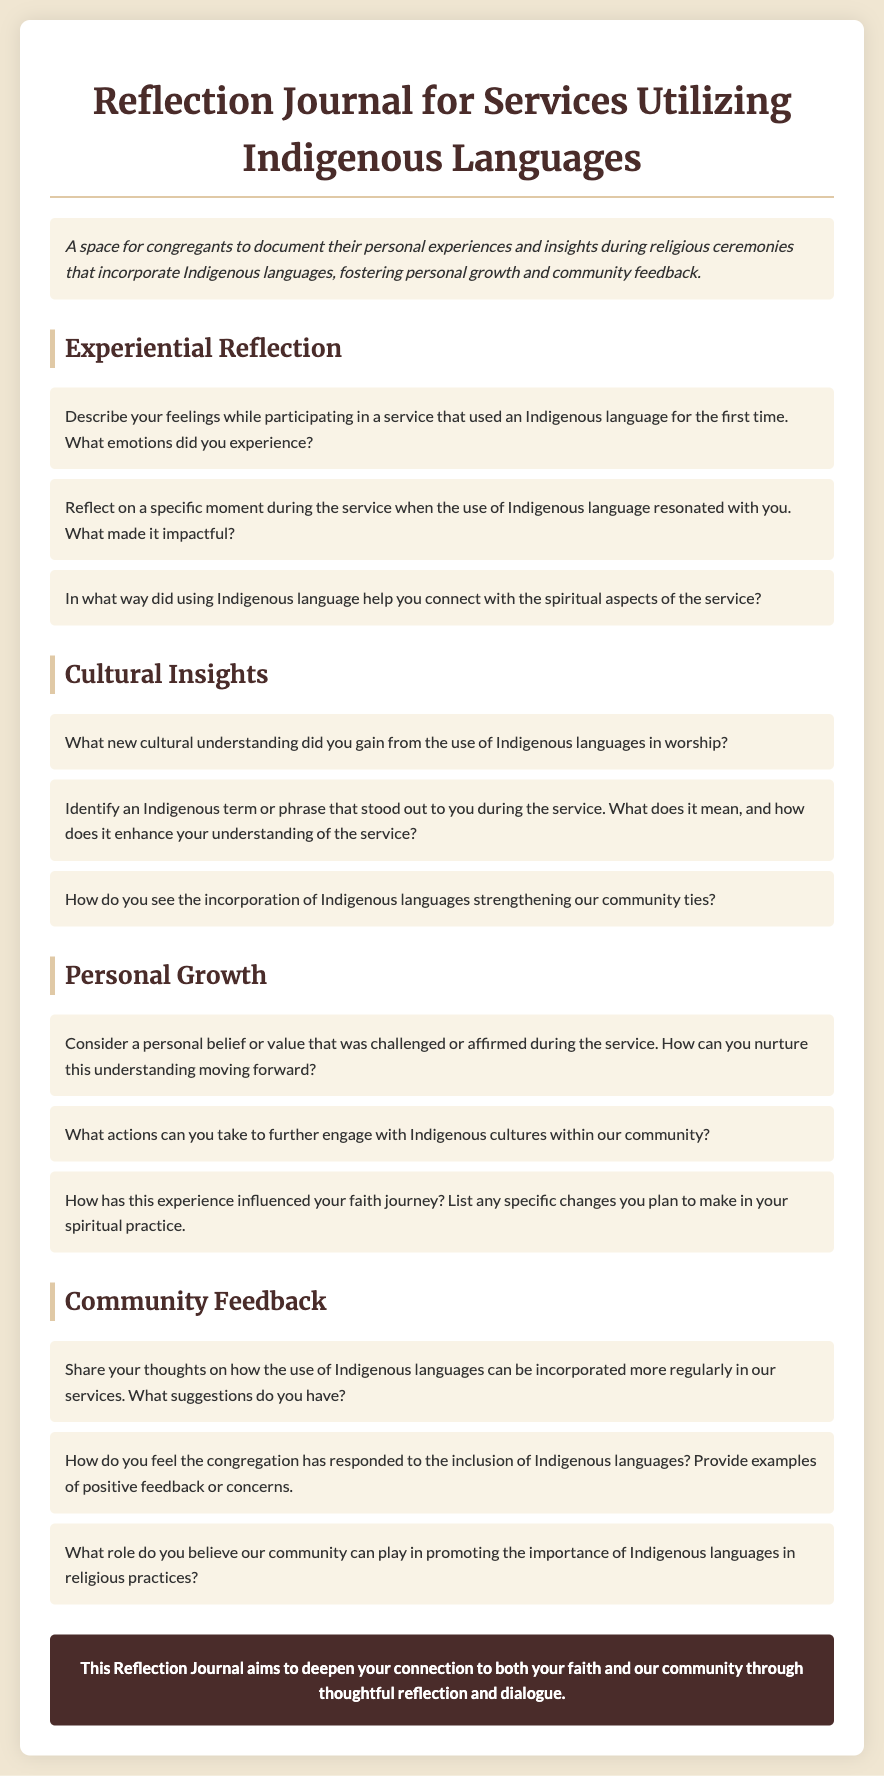what is the title of the reflection journal? The title is prominently displayed at the top of the document.
Answer: Reflection Journal for Services Utilizing Indigenous Languages what is the purpose of the journal? The purpose section describes the intention behind the journal.
Answer: A space for congregants to document their personal experiences and insights during religious ceremonies that incorporate Indigenous languages, fostering personal growth and community feedback how many sections are there in the document? The document contains multiple sections, and each section is clearly defined with a heading.
Answer: Four what is one prompt from the "Experiential Reflection" section? The document lists several prompts under this section.
Answer: Describe your feelings while participating in a service that used an Indigenous language for the first time. What emotions did you experience? which section discusses community feedback? This section is explicitly mentioned in the headings throughout the document.
Answer: Community Feedback what is the background color of the journal's body? The body color is specified in the styling section of the document.
Answer: #f0e6d2 what type of language is focused on in the journal? The type of language is mentioned in the title and purpose of the document.
Answer: Indigenous languages what feelings are congregants encouraged to reflect on? The journal prompts encourage reflection on emotions experienced during services.
Answer: Feelings while participating in a service 